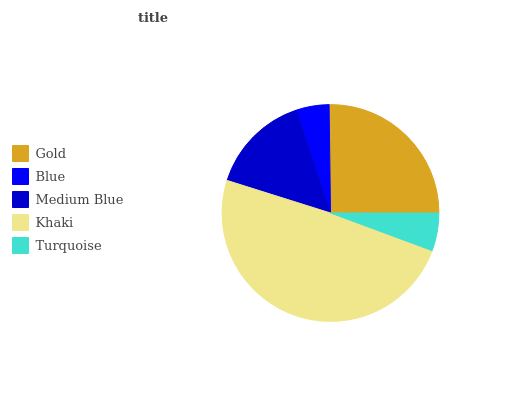Is Blue the minimum?
Answer yes or no. Yes. Is Khaki the maximum?
Answer yes or no. Yes. Is Medium Blue the minimum?
Answer yes or no. No. Is Medium Blue the maximum?
Answer yes or no. No. Is Medium Blue greater than Blue?
Answer yes or no. Yes. Is Blue less than Medium Blue?
Answer yes or no. Yes. Is Blue greater than Medium Blue?
Answer yes or no. No. Is Medium Blue less than Blue?
Answer yes or no. No. Is Medium Blue the high median?
Answer yes or no. Yes. Is Medium Blue the low median?
Answer yes or no. Yes. Is Khaki the high median?
Answer yes or no. No. Is Gold the low median?
Answer yes or no. No. 